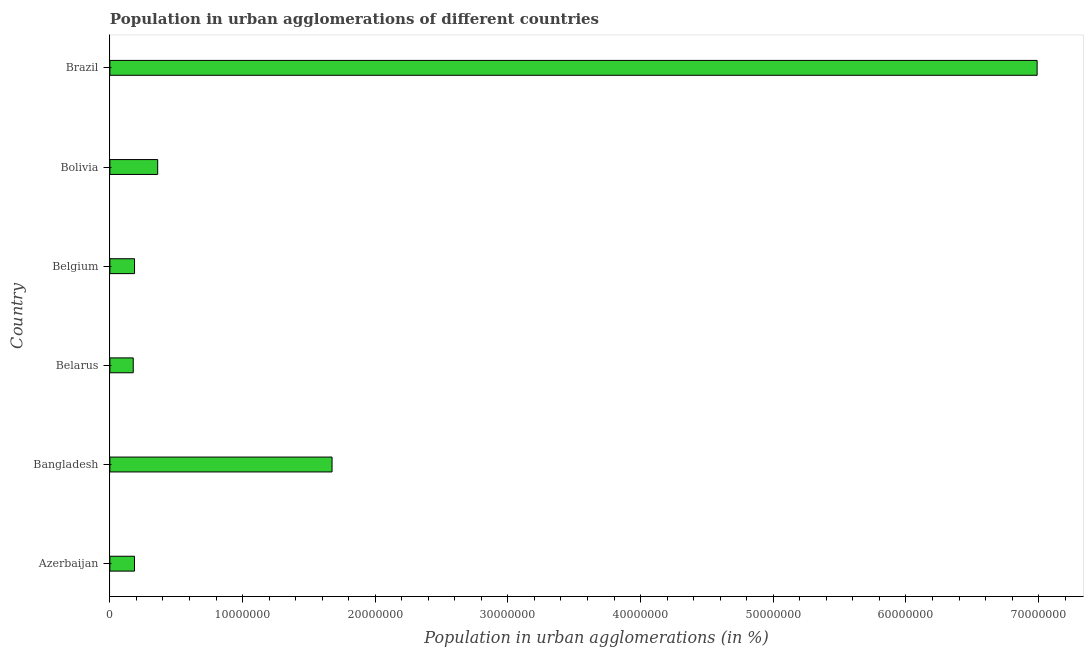Does the graph contain grids?
Keep it short and to the point. No. What is the title of the graph?
Your answer should be very brief. Population in urban agglomerations of different countries. What is the label or title of the X-axis?
Offer a very short reply. Population in urban agglomerations (in %). What is the label or title of the Y-axis?
Offer a very short reply. Country. What is the population in urban agglomerations in Bangladesh?
Keep it short and to the point. 1.67e+07. Across all countries, what is the maximum population in urban agglomerations?
Provide a short and direct response. 6.99e+07. Across all countries, what is the minimum population in urban agglomerations?
Offer a terse response. 1.76e+06. In which country was the population in urban agglomerations minimum?
Ensure brevity in your answer.  Belarus. What is the sum of the population in urban agglomerations?
Keep it short and to the point. 9.57e+07. What is the difference between the population in urban agglomerations in Belarus and Bolivia?
Make the answer very short. -1.84e+06. What is the average population in urban agglomerations per country?
Give a very brief answer. 1.60e+07. What is the median population in urban agglomerations?
Your response must be concise. 2.73e+06. In how many countries, is the population in urban agglomerations greater than 16000000 %?
Give a very brief answer. 2. What is the ratio of the population in urban agglomerations in Belarus to that in Brazil?
Give a very brief answer. 0.03. Is the difference between the population in urban agglomerations in Azerbaijan and Belgium greater than the difference between any two countries?
Give a very brief answer. No. What is the difference between the highest and the second highest population in urban agglomerations?
Provide a short and direct response. 5.31e+07. What is the difference between the highest and the lowest population in urban agglomerations?
Provide a succinct answer. 6.81e+07. In how many countries, is the population in urban agglomerations greater than the average population in urban agglomerations taken over all countries?
Offer a terse response. 2. How many bars are there?
Make the answer very short. 6. How many countries are there in the graph?
Your answer should be very brief. 6. What is the difference between two consecutive major ticks on the X-axis?
Offer a very short reply. 1.00e+07. What is the Population in urban agglomerations (in %) in Azerbaijan?
Give a very brief answer. 1.85e+06. What is the Population in urban agglomerations (in %) of Bangladesh?
Offer a very short reply. 1.67e+07. What is the Population in urban agglomerations (in %) of Belarus?
Keep it short and to the point. 1.76e+06. What is the Population in urban agglomerations (in %) of Belgium?
Keep it short and to the point. 1.86e+06. What is the Population in urban agglomerations (in %) of Bolivia?
Keep it short and to the point. 3.60e+06. What is the Population in urban agglomerations (in %) in Brazil?
Provide a short and direct response. 6.99e+07. What is the difference between the Population in urban agglomerations (in %) in Azerbaijan and Bangladesh?
Offer a terse response. -1.49e+07. What is the difference between the Population in urban agglomerations (in %) in Azerbaijan and Belarus?
Provide a short and direct response. 9.54e+04. What is the difference between the Population in urban agglomerations (in %) in Azerbaijan and Belgium?
Keep it short and to the point. -2116. What is the difference between the Population in urban agglomerations (in %) in Azerbaijan and Bolivia?
Keep it short and to the point. -1.75e+06. What is the difference between the Population in urban agglomerations (in %) in Azerbaijan and Brazil?
Ensure brevity in your answer.  -6.80e+07. What is the difference between the Population in urban agglomerations (in %) in Bangladesh and Belarus?
Your response must be concise. 1.50e+07. What is the difference between the Population in urban agglomerations (in %) in Bangladesh and Belgium?
Provide a short and direct response. 1.49e+07. What is the difference between the Population in urban agglomerations (in %) in Bangladesh and Bolivia?
Offer a terse response. 1.31e+07. What is the difference between the Population in urban agglomerations (in %) in Bangladesh and Brazil?
Keep it short and to the point. -5.31e+07. What is the difference between the Population in urban agglomerations (in %) in Belarus and Belgium?
Your response must be concise. -9.75e+04. What is the difference between the Population in urban agglomerations (in %) in Belarus and Bolivia?
Provide a succinct answer. -1.84e+06. What is the difference between the Population in urban agglomerations (in %) in Belarus and Brazil?
Your answer should be compact. -6.81e+07. What is the difference between the Population in urban agglomerations (in %) in Belgium and Bolivia?
Provide a succinct answer. -1.75e+06. What is the difference between the Population in urban agglomerations (in %) in Belgium and Brazil?
Offer a very short reply. -6.80e+07. What is the difference between the Population in urban agglomerations (in %) in Bolivia and Brazil?
Give a very brief answer. -6.63e+07. What is the ratio of the Population in urban agglomerations (in %) in Azerbaijan to that in Bangladesh?
Offer a terse response. 0.11. What is the ratio of the Population in urban agglomerations (in %) in Azerbaijan to that in Belarus?
Keep it short and to the point. 1.05. What is the ratio of the Population in urban agglomerations (in %) in Azerbaijan to that in Belgium?
Provide a short and direct response. 1. What is the ratio of the Population in urban agglomerations (in %) in Azerbaijan to that in Bolivia?
Your answer should be very brief. 0.52. What is the ratio of the Population in urban agglomerations (in %) in Azerbaijan to that in Brazil?
Provide a short and direct response. 0.03. What is the ratio of the Population in urban agglomerations (in %) in Bangladesh to that in Belarus?
Give a very brief answer. 9.52. What is the ratio of the Population in urban agglomerations (in %) in Bangladesh to that in Belgium?
Offer a very short reply. 9.02. What is the ratio of the Population in urban agglomerations (in %) in Bangladesh to that in Bolivia?
Ensure brevity in your answer.  4.65. What is the ratio of the Population in urban agglomerations (in %) in Bangladesh to that in Brazil?
Offer a very short reply. 0.24. What is the ratio of the Population in urban agglomerations (in %) in Belarus to that in Belgium?
Your response must be concise. 0.95. What is the ratio of the Population in urban agglomerations (in %) in Belarus to that in Bolivia?
Give a very brief answer. 0.49. What is the ratio of the Population in urban agglomerations (in %) in Belarus to that in Brazil?
Ensure brevity in your answer.  0.03. What is the ratio of the Population in urban agglomerations (in %) in Belgium to that in Bolivia?
Keep it short and to the point. 0.52. What is the ratio of the Population in urban agglomerations (in %) in Belgium to that in Brazil?
Keep it short and to the point. 0.03. What is the ratio of the Population in urban agglomerations (in %) in Bolivia to that in Brazil?
Make the answer very short. 0.05. 